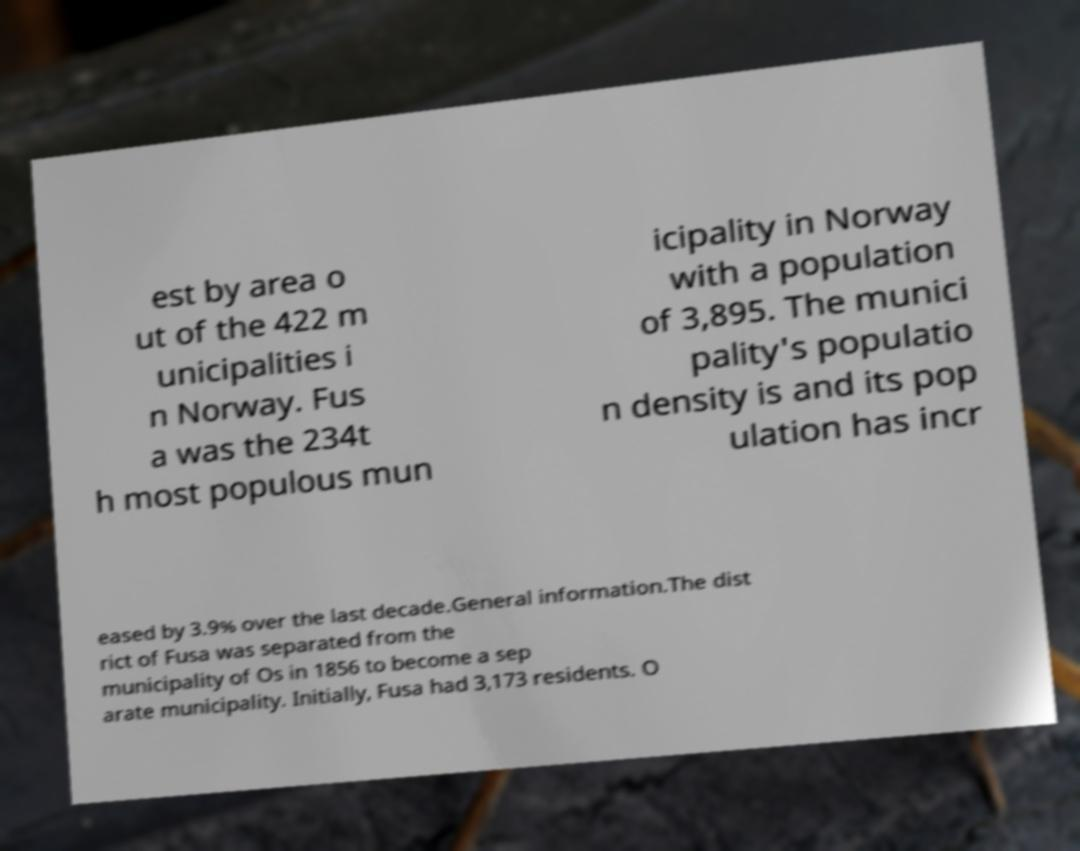There's text embedded in this image that I need extracted. Can you transcribe it verbatim? est by area o ut of the 422 m unicipalities i n Norway. Fus a was the 234t h most populous mun icipality in Norway with a population of 3,895. The munici pality's populatio n density is and its pop ulation has incr eased by 3.9% over the last decade.General information.The dist rict of Fusa was separated from the municipality of Os in 1856 to become a sep arate municipality. Initially, Fusa had 3,173 residents. O 